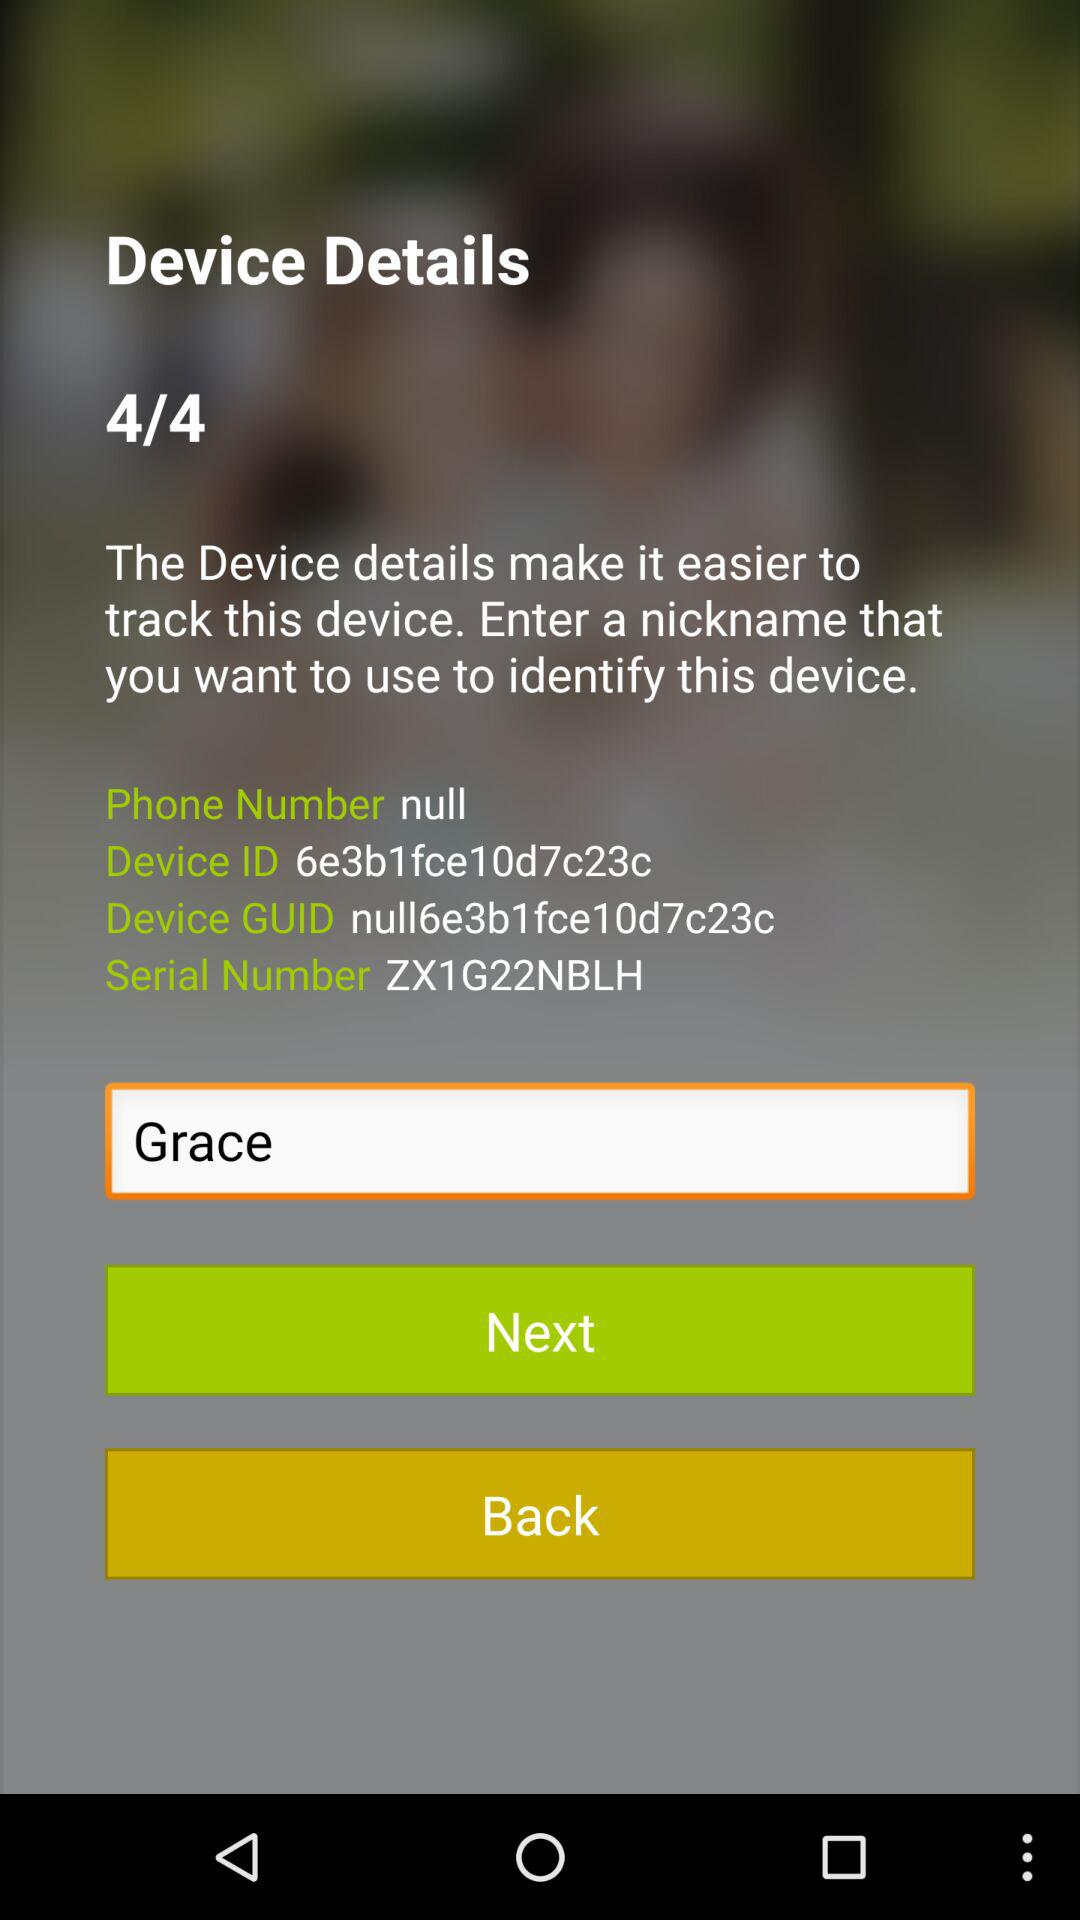What is the serial number of the device? The serial number of the device is ZX1G22NBLH. 